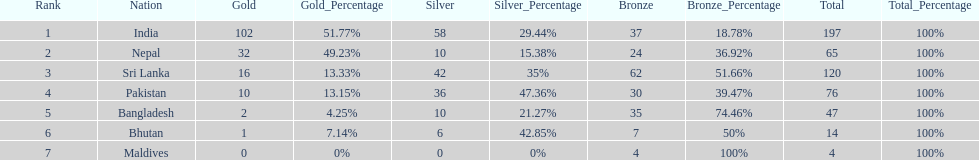How many gold medals did india win? 102. 